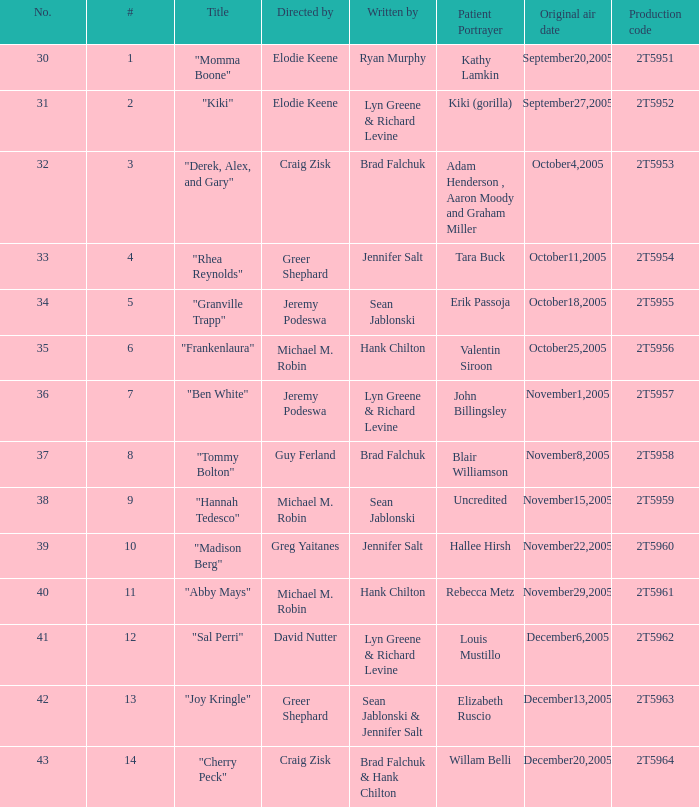Who are the authors of the episode called "ben white"? Lyn Greene & Richard Levine. 